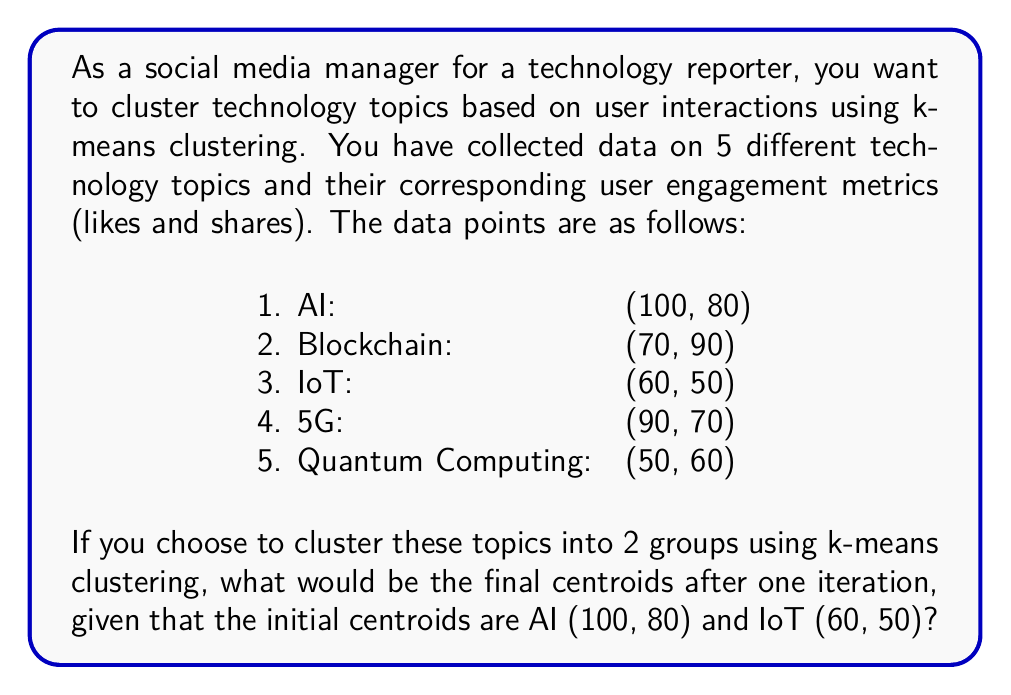Show me your answer to this math problem. To solve this problem using k-means clustering, we'll follow these steps:

1. Identify the initial centroids:
   Centroid 1 (C1): AI (100, 80)
   Centroid 2 (C2): IoT (60, 50)

2. Calculate the Euclidean distance between each data point and the centroids:

   For each point $(x, y)$ and centroid $(c_x, c_y)$, the distance is:
   $$d = \sqrt{(x - c_x)^2 + (y - c_y)^2}$$

   AI (100, 80): 
   d(C1) = 0, d(C2) = 50

   Blockchain (70, 90):
   d(C1) = $\sqrt{(70-100)^2 + (90-80)^2} \approx 32.02$
   d(C2) = $\sqrt{(70-60)^2 + (90-50)^2} \approx 41.23$

   IoT (60, 50):
   d(C1) = 50, d(C2) = 0

   5G (90, 70):
   d(C1) = $\sqrt{(90-100)^2 + (70-80)^2} \approx 14.14$
   d(C2) = $\sqrt{(90-60)^2 + (70-50)^2} \approx 36.06$

   Quantum Computing (50, 60):
   d(C1) = $\sqrt{(50-100)^2 + (60-80)^2} \approx 56.57$
   d(C2) = $\sqrt{(50-60)^2 + (60-50)^2} \approx 14.14$

3. Assign each point to the nearest centroid:
   Cluster 1 (C1): AI, Blockchain, 5G
   Cluster 2 (C2): IoT, Quantum Computing

4. Calculate new centroids by taking the mean of all points in each cluster:

   New C1: $(\frac{100+70+90}{3}, \frac{80+90+70}{3}) = (86.67, 80)$
   New C2: $(\frac{60+50}{2}, \frac{50+60}{2}) = (55, 55)$

The final centroids after one iteration are (86.67, 80) and (55, 55).
Answer: The final centroids after one iteration of k-means clustering are:
Centroid 1: (86.67, 80)
Centroid 2: (55, 55) 